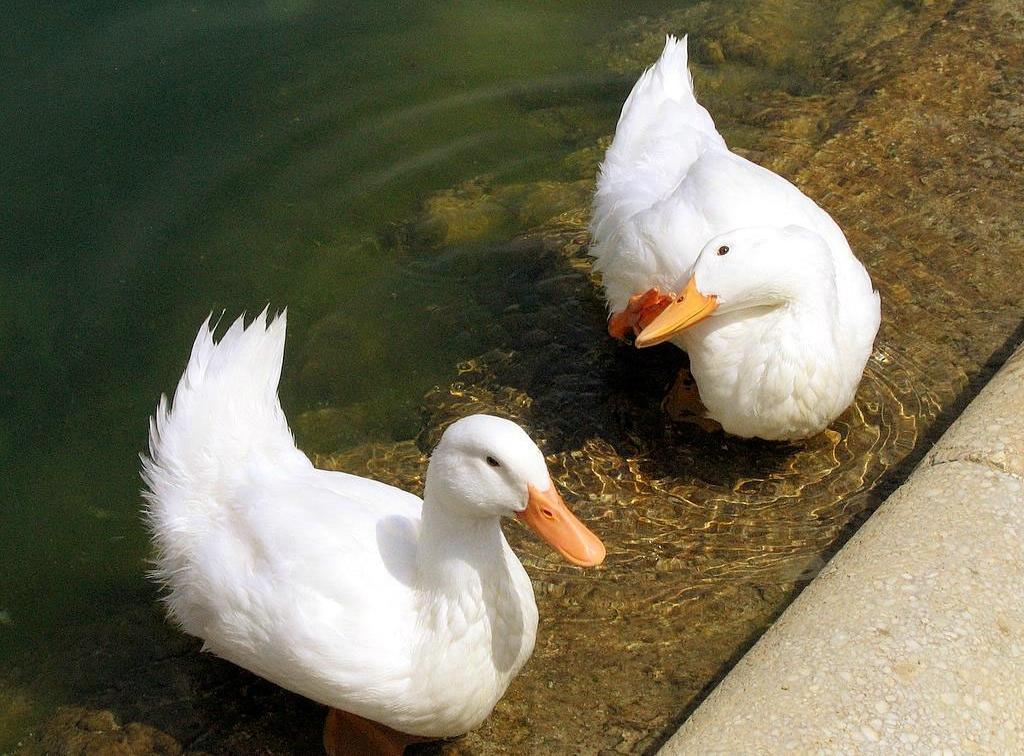Could you give a brief overview of what you see in this image? In this image there are two ducks swimming in the water. In the bottom right there is the ground. In the background there is water. 